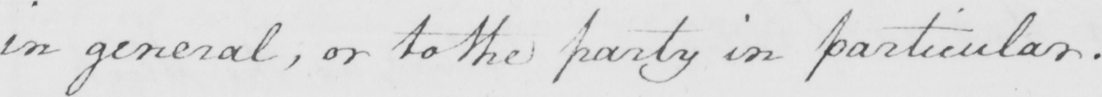What is written in this line of handwriting? in general , or to the party in particular . 